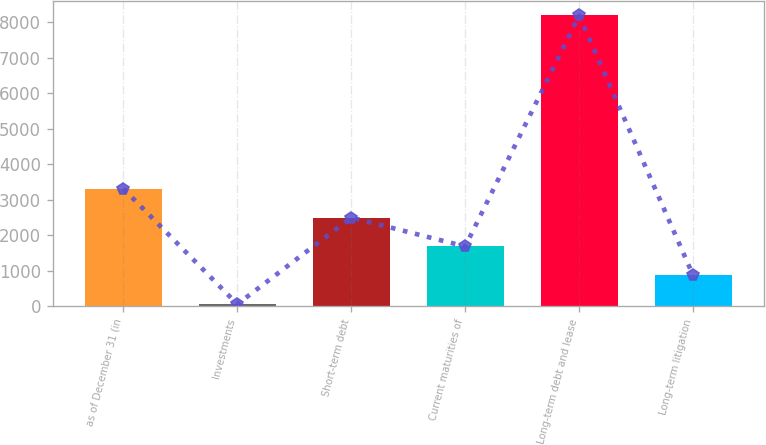<chart> <loc_0><loc_0><loc_500><loc_500><bar_chart><fcel>as of December 31 (in<fcel>Investments<fcel>Short-term debt<fcel>Current maturities of<fcel>Long-term debt and lease<fcel>Long-term litigation<nl><fcel>3308<fcel>52<fcel>2494<fcel>1680<fcel>8192<fcel>866<nl></chart> 